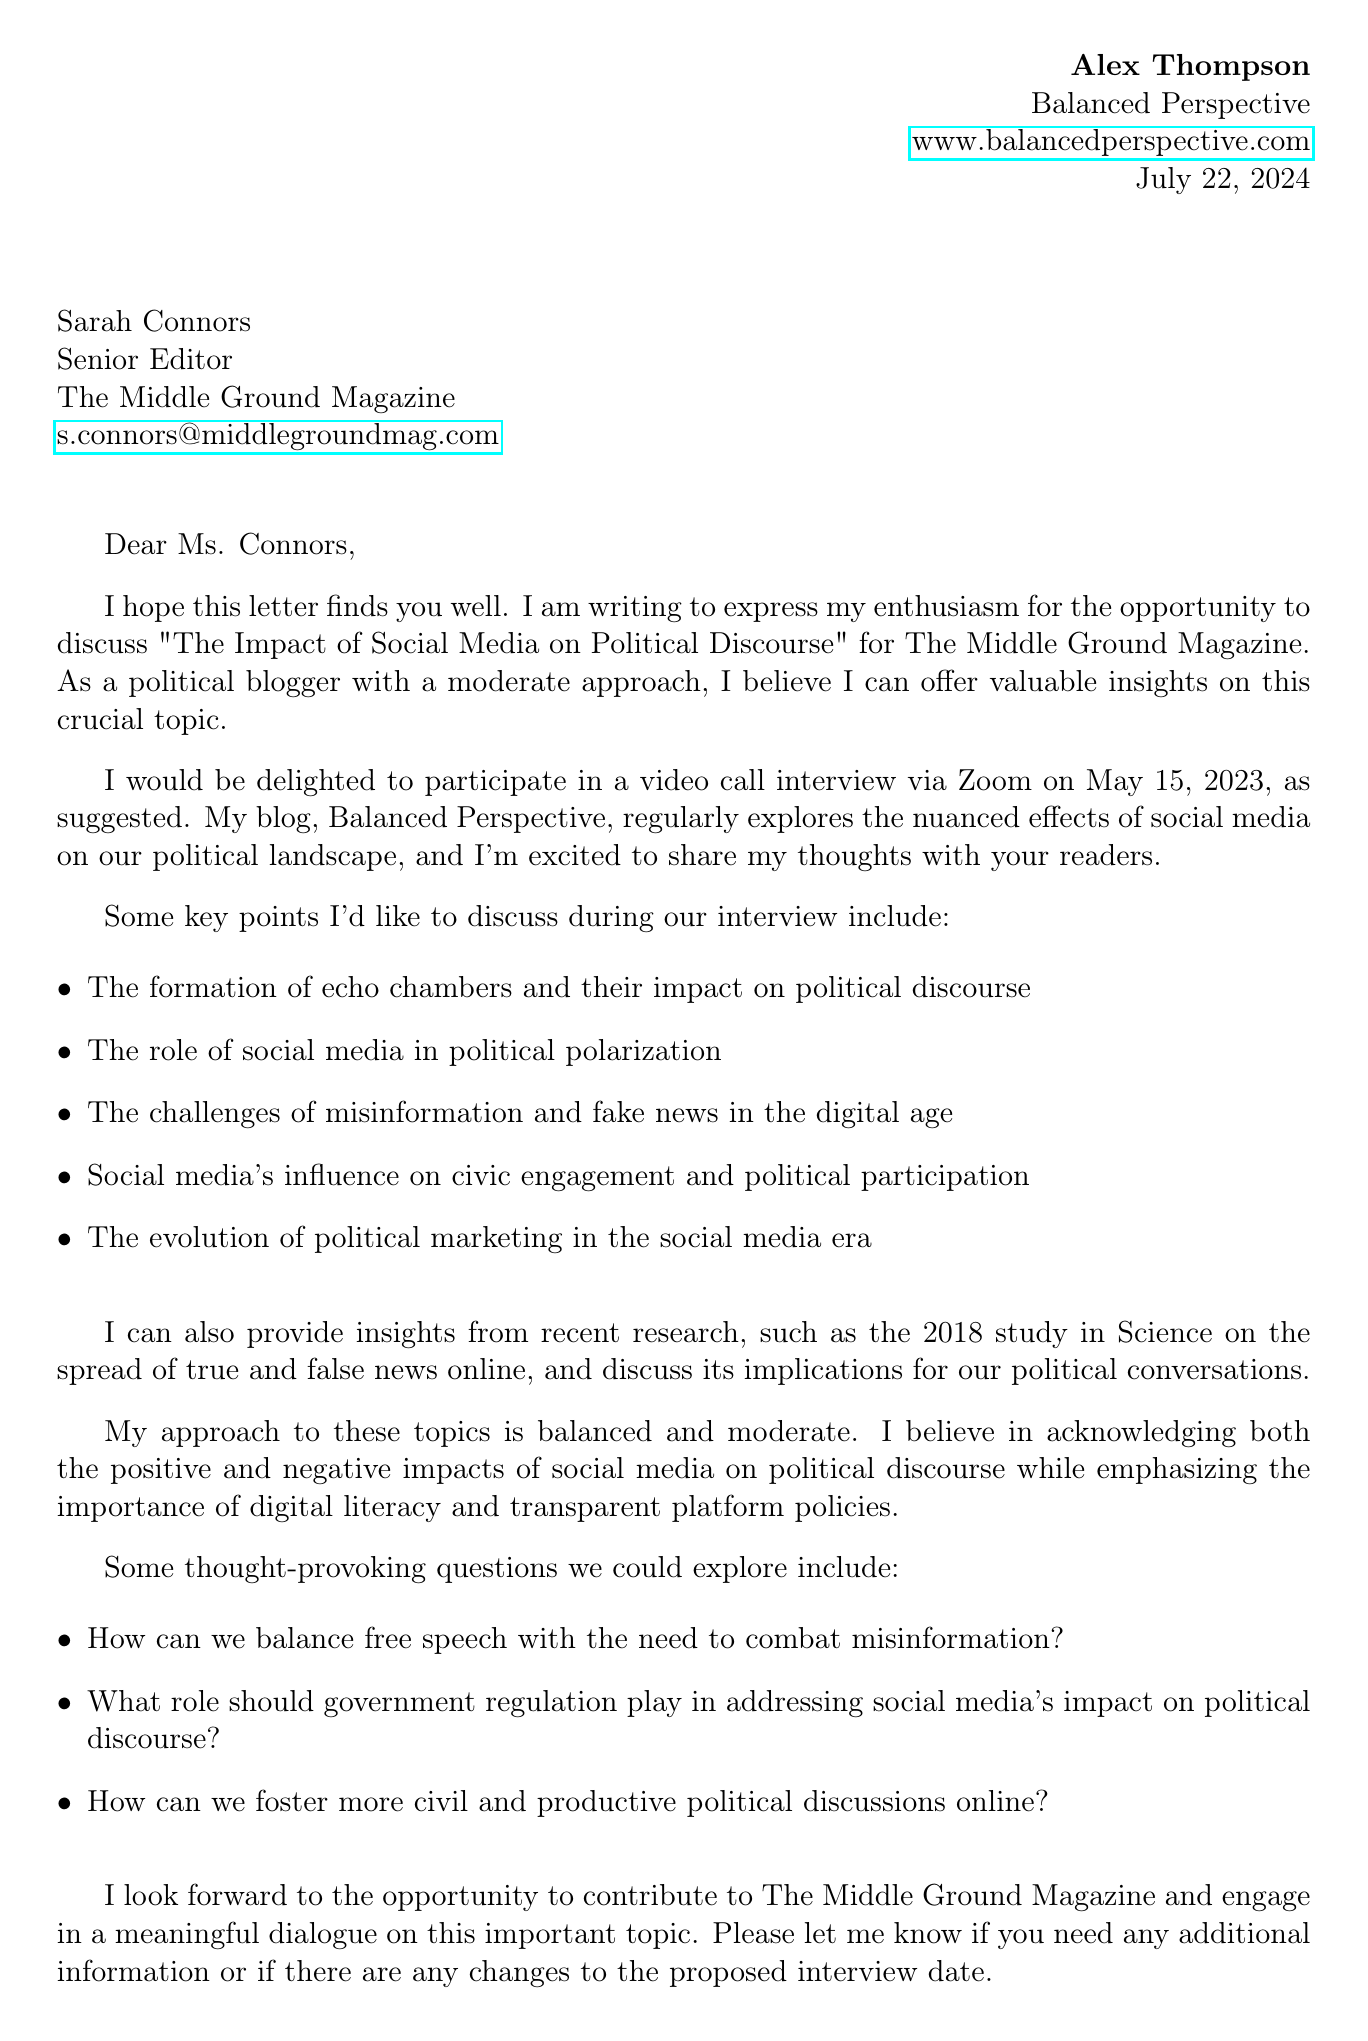What is the name of the sender? The sender's name is stated in the opening of the letter.
Answer: Alex Thompson What is the suggested date for the interview? The suggested date for the interview is mentioned explicitly in the letter.
Answer: May 15, 2023 What is the topic of discussion for the interview? The topic of discussion is clearly outlined at the beginning of the letter.
Answer: The Impact of Social Media on Political Discourse Who is the recipient of the letter? The recipient's name and position are provided at the start of the letter.
Answer: Sarah Connors What is one of the key points mentioned for discussion? The letter lists key points that will be discussed during the interview.
Answer: The formation of echo chambers and their impact on political discourse How does the sender describe their approach to the topic? The sender expresses their perspective on the topic in a specific phrase within the letter.
Answer: Moderate and balanced What is one of the recent blog posts mentioned? The letter provides examples of recent blog posts related to the topic.
Answer: The Double-Edged Sword of Twitter in Political Campaigns What is the role of social media discussed in relation to political participation? The letter includes specific discussions around social media's influence.
Answer: Increased political participation and awareness What are potential questions for the interview mentioned in the letter? The letter explicitly lists several thought-provoking questions for consideration.
Answer: How can we balance free speech with the need to combat misinformation? 